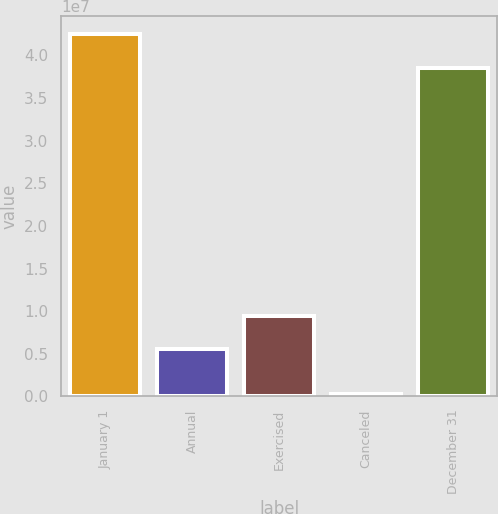Convert chart to OTSL. <chart><loc_0><loc_0><loc_500><loc_500><bar_chart><fcel>January 1<fcel>Annual<fcel>Exercised<fcel>Canceled<fcel>December 31<nl><fcel>4.24526e+07<fcel>5.52954e+06<fcel>9.42967e+06<fcel>234274<fcel>3.85524e+07<nl></chart> 